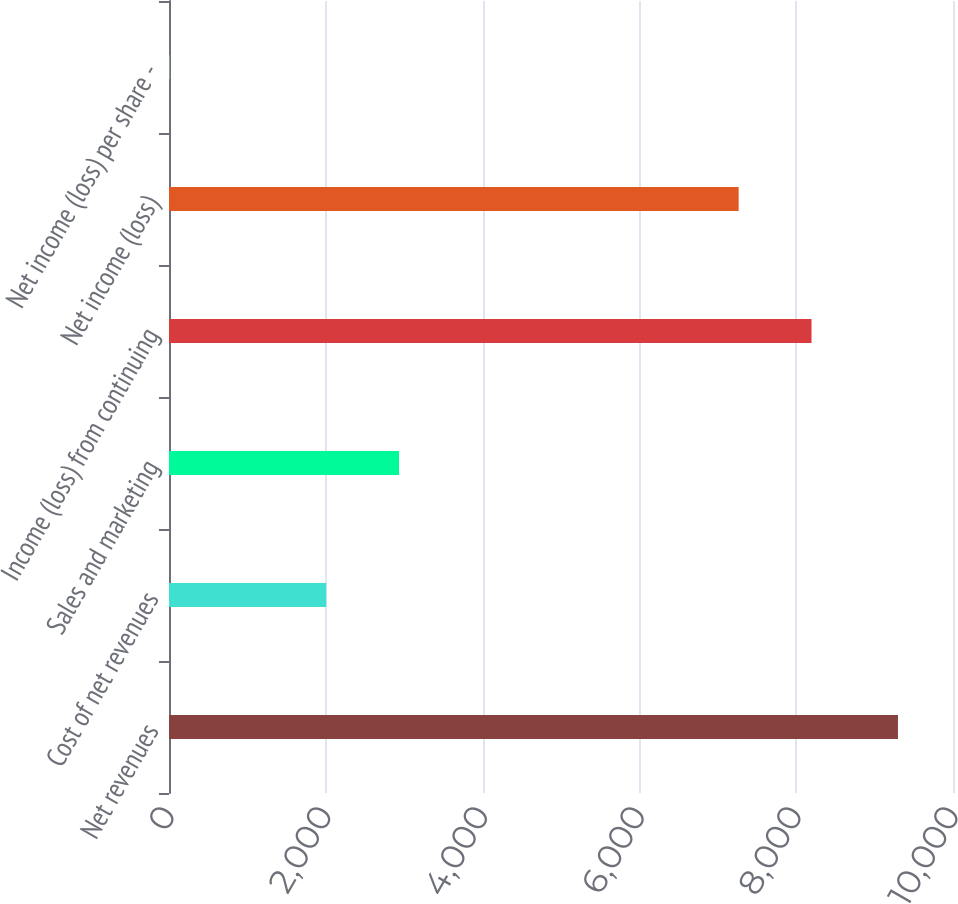Convert chart. <chart><loc_0><loc_0><loc_500><loc_500><bar_chart><fcel>Net revenues<fcel>Cost of net revenues<fcel>Sales and marketing<fcel>Income (loss) from continuing<fcel>Net income (loss)<fcel>Net income (loss) per share -<nl><fcel>9298<fcel>2005<fcel>2934.16<fcel>8195.17<fcel>7266<fcel>6.35<nl></chart> 